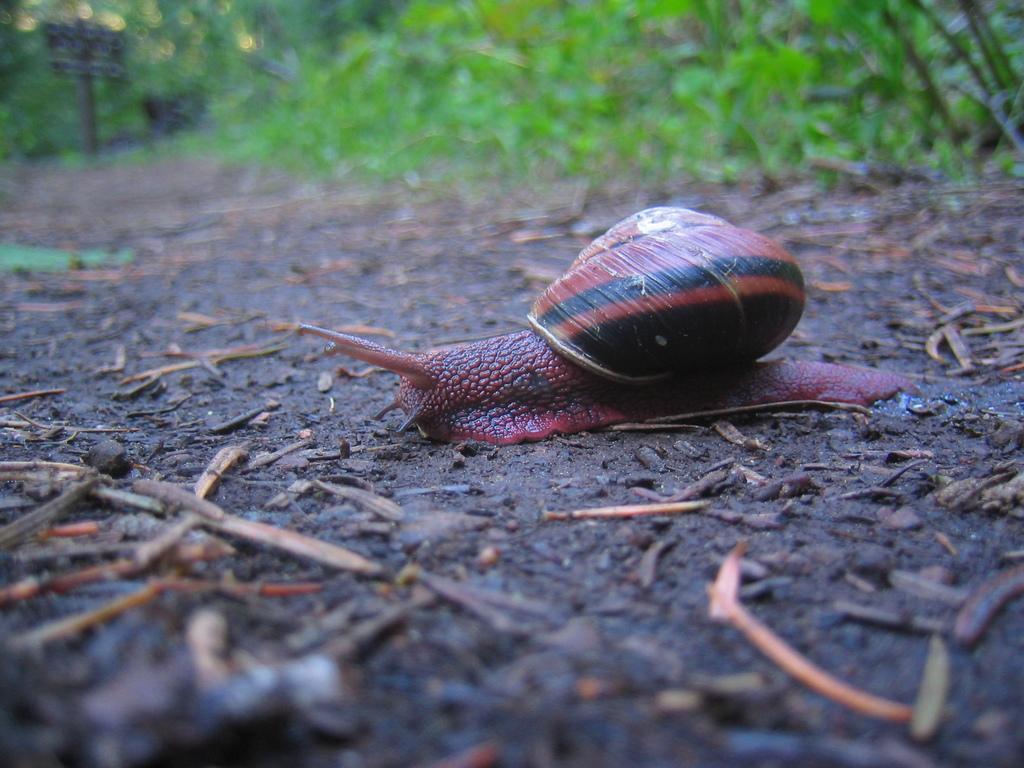Can you describe this image briefly? In this image we can see a snail on the ground, there are some sticks and leaves on the ground, also we can see some plants, and bushes. 